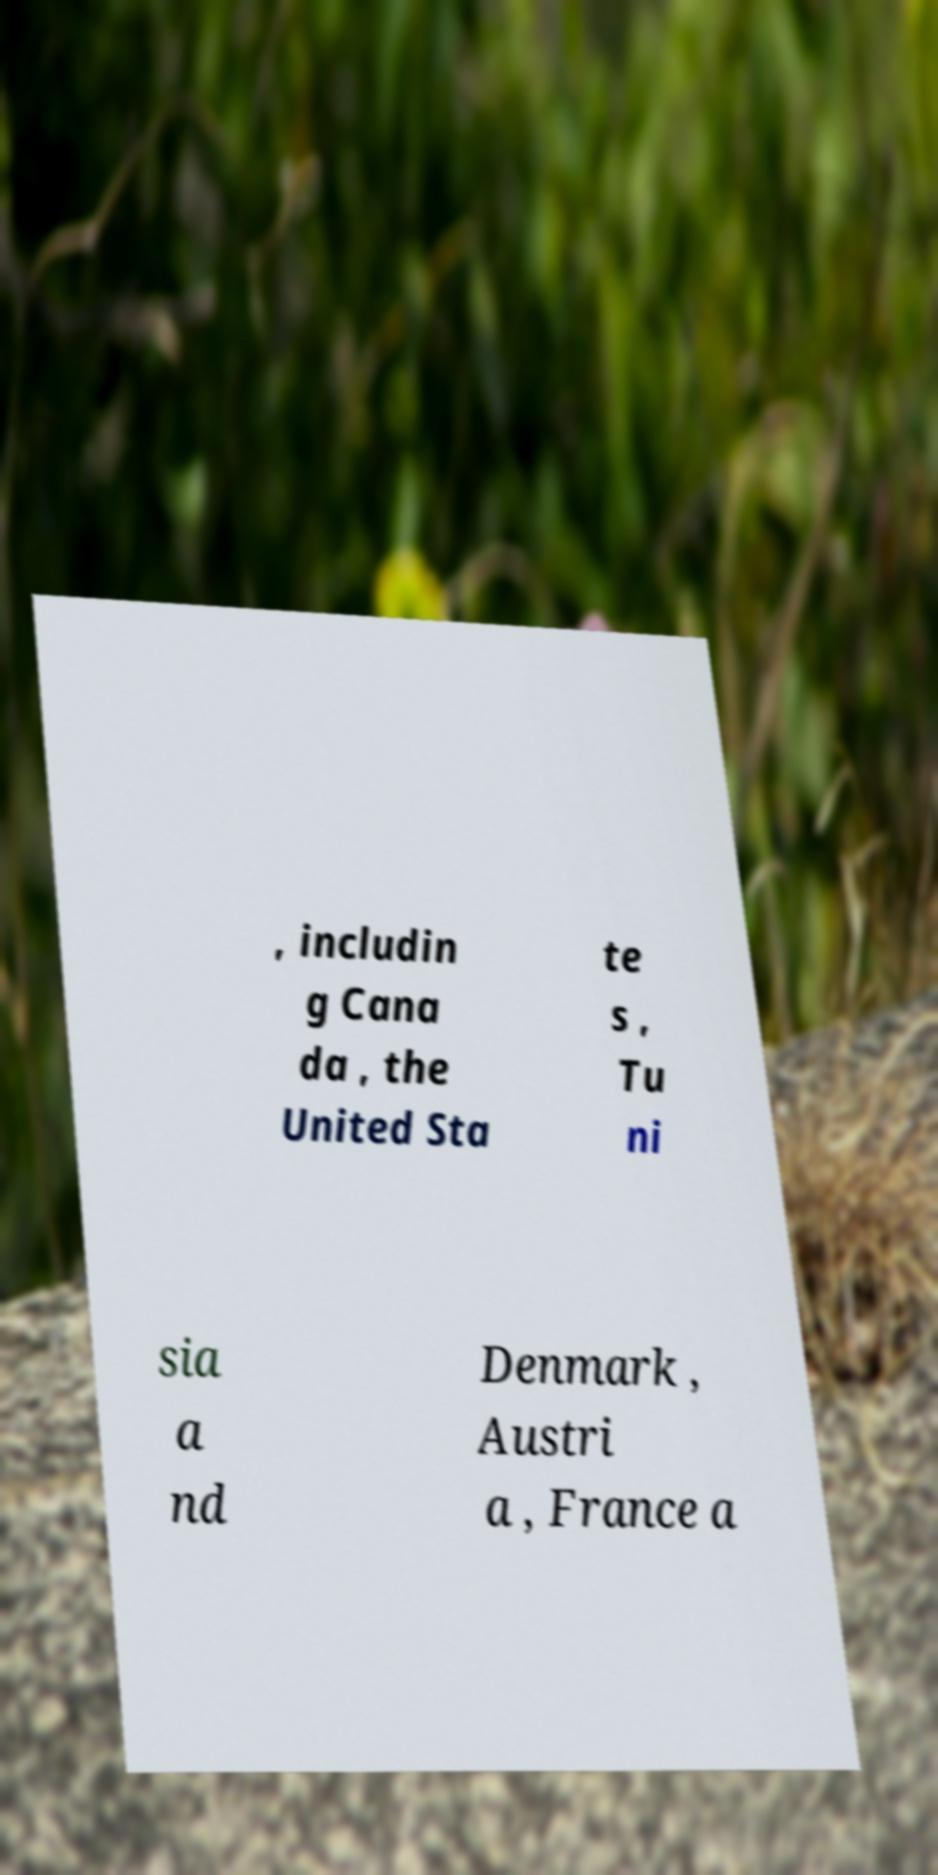Could you extract and type out the text from this image? , includin g Cana da , the United Sta te s , Tu ni sia a nd Denmark , Austri a , France a 